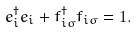Convert formula to latex. <formula><loc_0><loc_0><loc_500><loc_500>e _ { i } ^ { \dagger } e _ { i } + f ^ { \dagger } _ { i \sigma } f _ { i \sigma } = 1 .</formula> 